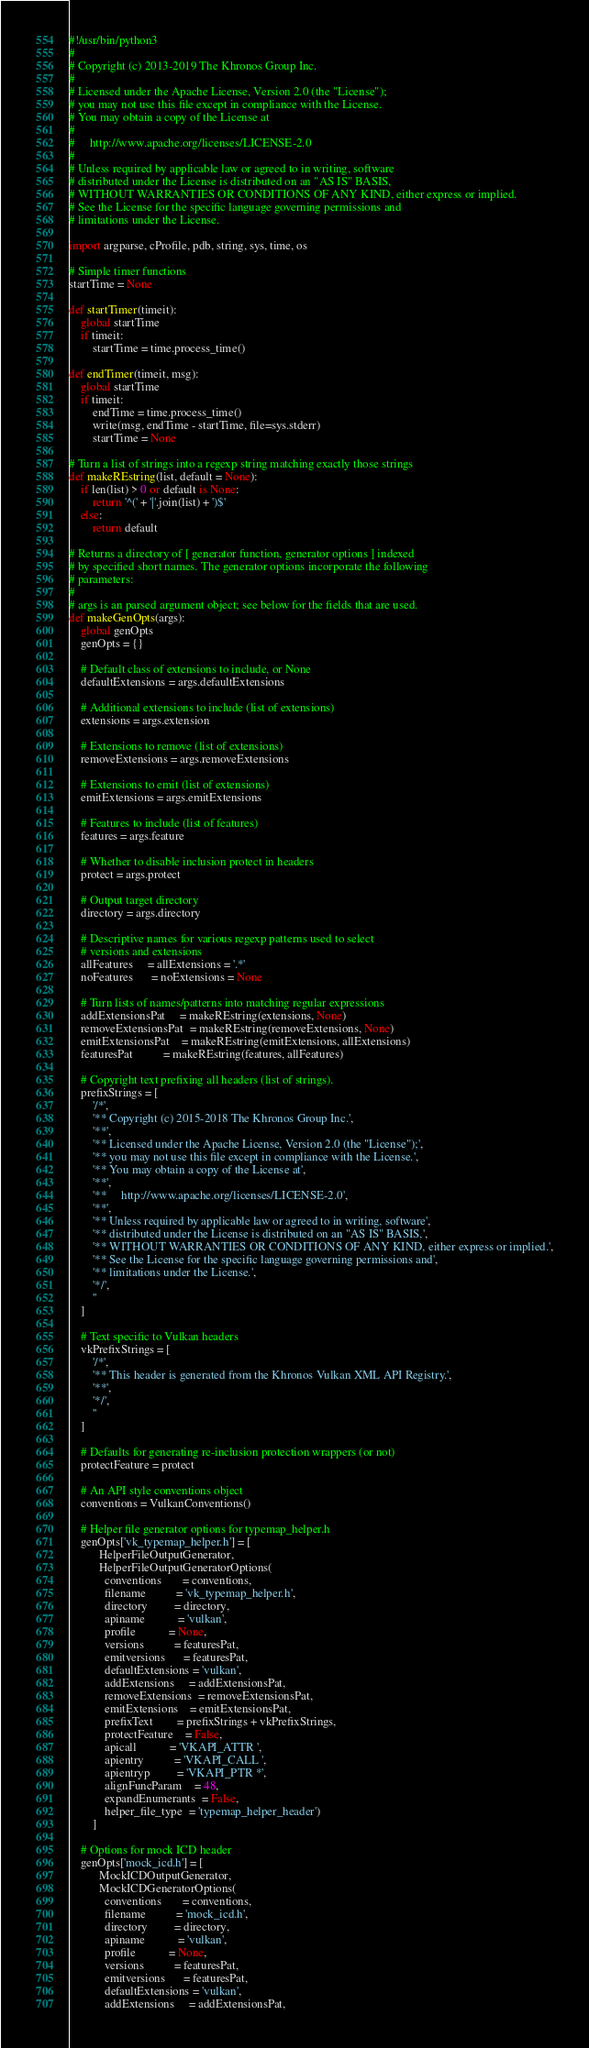<code> <loc_0><loc_0><loc_500><loc_500><_Python_>#!/usr/bin/python3
#
# Copyright (c) 2013-2019 The Khronos Group Inc.
#
# Licensed under the Apache License, Version 2.0 (the "License");
# you may not use this file except in compliance with the License.
# You may obtain a copy of the License at
#
#     http://www.apache.org/licenses/LICENSE-2.0
#
# Unless required by applicable law or agreed to in writing, software
# distributed under the License is distributed on an "AS IS" BASIS,
# WITHOUT WARRANTIES OR CONDITIONS OF ANY KIND, either express or implied.
# See the License for the specific language governing permissions and
# limitations under the License.

import argparse, cProfile, pdb, string, sys, time, os

# Simple timer functions
startTime = None

def startTimer(timeit):
    global startTime
    if timeit:
        startTime = time.process_time()

def endTimer(timeit, msg):
    global startTime
    if timeit:
        endTime = time.process_time()
        write(msg, endTime - startTime, file=sys.stderr)
        startTime = None

# Turn a list of strings into a regexp string matching exactly those strings
def makeREstring(list, default = None):
    if len(list) > 0 or default is None:
        return '^(' + '|'.join(list) + ')$'
    else:
        return default

# Returns a directory of [ generator function, generator options ] indexed
# by specified short names. The generator options incorporate the following
# parameters:
#
# args is an parsed argument object; see below for the fields that are used.
def makeGenOpts(args):
    global genOpts
    genOpts = {}

    # Default class of extensions to include, or None
    defaultExtensions = args.defaultExtensions

    # Additional extensions to include (list of extensions)
    extensions = args.extension

    # Extensions to remove (list of extensions)
    removeExtensions = args.removeExtensions

    # Extensions to emit (list of extensions)
    emitExtensions = args.emitExtensions

    # Features to include (list of features)
    features = args.feature

    # Whether to disable inclusion protect in headers
    protect = args.protect

    # Output target directory
    directory = args.directory

    # Descriptive names for various regexp patterns used to select
    # versions and extensions
    allFeatures     = allExtensions = '.*'
    noFeatures      = noExtensions = None

    # Turn lists of names/patterns into matching regular expressions
    addExtensionsPat     = makeREstring(extensions, None)
    removeExtensionsPat  = makeREstring(removeExtensions, None)
    emitExtensionsPat    = makeREstring(emitExtensions, allExtensions)
    featuresPat          = makeREstring(features, allFeatures)

    # Copyright text prefixing all headers (list of strings).
    prefixStrings = [
        '/*',
        '** Copyright (c) 2015-2018 The Khronos Group Inc.',
        '**',
        '** Licensed under the Apache License, Version 2.0 (the "License");',
        '** you may not use this file except in compliance with the License.',
        '** You may obtain a copy of the License at',
        '**',
        '**     http://www.apache.org/licenses/LICENSE-2.0',
        '**',
        '** Unless required by applicable law or agreed to in writing, software',
        '** distributed under the License is distributed on an "AS IS" BASIS,',
        '** WITHOUT WARRANTIES OR CONDITIONS OF ANY KIND, either express or implied.',
        '** See the License for the specific language governing permissions and',
        '** limitations under the License.',
        '*/',
        ''
    ]

    # Text specific to Vulkan headers
    vkPrefixStrings = [
        '/*',
        '** This header is generated from the Khronos Vulkan XML API Registry.',
        '**',
        '*/',
        ''
    ]

    # Defaults for generating re-inclusion protection wrappers (or not)
    protectFeature = protect

    # An API style conventions object
    conventions = VulkanConventions()

    # Helper file generator options for typemap_helper.h
    genOpts['vk_typemap_helper.h'] = [
          HelperFileOutputGenerator,
          HelperFileOutputGeneratorOptions(
            conventions       = conventions,
            filename          = 'vk_typemap_helper.h',
            directory         = directory,
            apiname           = 'vulkan',
            profile           = None,
            versions          = featuresPat,
            emitversions      = featuresPat,
            defaultExtensions = 'vulkan',
            addExtensions     = addExtensionsPat,
            removeExtensions  = removeExtensionsPat,
            emitExtensions    = emitExtensionsPat,
            prefixText        = prefixStrings + vkPrefixStrings,
            protectFeature    = False,
            apicall           = 'VKAPI_ATTR ',
            apientry          = 'VKAPI_CALL ',
            apientryp         = 'VKAPI_PTR *',
            alignFuncParam    = 48,
            expandEnumerants  = False,
            helper_file_type  = 'typemap_helper_header')
        ]

    # Options for mock ICD header
    genOpts['mock_icd.h'] = [
          MockICDOutputGenerator,
          MockICDGeneratorOptions(
            conventions       = conventions,
            filename          = 'mock_icd.h',
            directory         = directory,
            apiname           = 'vulkan',
            profile           = None,
            versions          = featuresPat,
            emitversions      = featuresPat,
            defaultExtensions = 'vulkan',
            addExtensions     = addExtensionsPat,</code> 